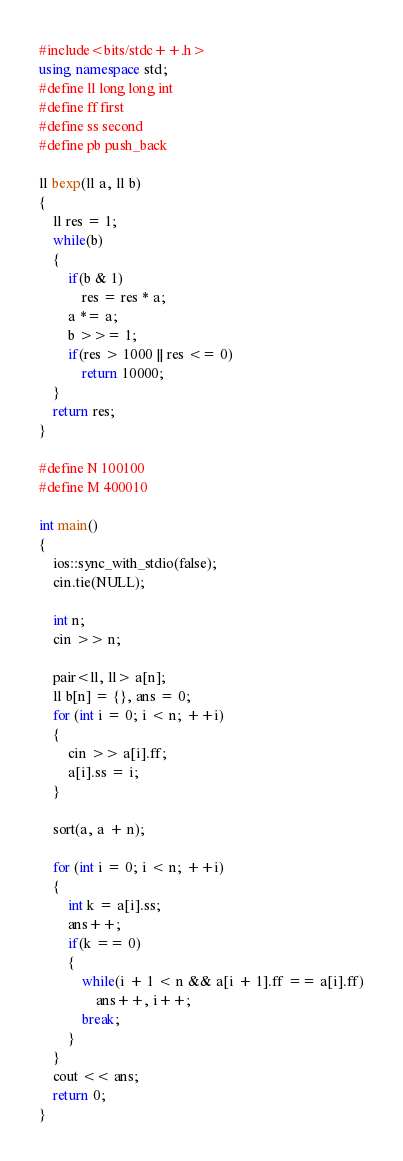<code> <loc_0><loc_0><loc_500><loc_500><_C++_>#include<bits/stdc++.h>
using namespace std;
#define ll long long int
#define ff first
#define ss second
#define pb push_back

ll bexp(ll a, ll b)
{
	ll res = 1;
	while(b)
	{
		if(b & 1)
			res = res * a;
		a *= a;
		b >>= 1;
		if(res > 1000 || res <= 0)
			return 10000;
	}
	return res;
}

#define N 100100
#define M 400010

int main()
{
	ios::sync_with_stdio(false);
	cin.tie(NULL);

	int n;
	cin >> n;

	pair<ll, ll> a[n];
	ll b[n] = {}, ans = 0;
	for (int i = 0; i < n; ++i)
	{
		cin >> a[i].ff;
		a[i].ss = i;
	}

	sort(a, a + n);

	for (int i = 0; i < n; ++i)
	{
		int k = a[i].ss;
		ans++;
		if(k == 0)
		{
			while(i + 1 < n && a[i + 1].ff == a[i].ff)
				ans++, i++;
			break;
		}
	}
	cout << ans;
	return 0; 
}
</code> 